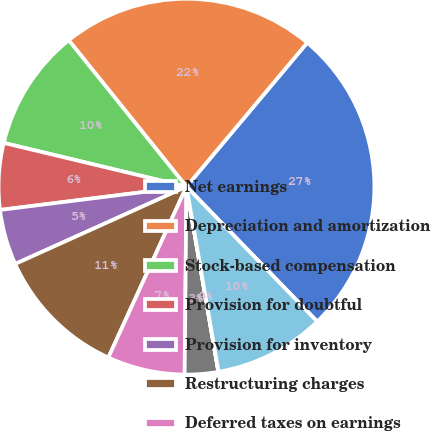Convert chart to OTSL. <chart><loc_0><loc_0><loc_500><loc_500><pie_chart><fcel>Net earnings<fcel>Depreciation and amortization<fcel>Stock-based compensation<fcel>Provision for doubtful<fcel>Provision for inventory<fcel>Restructuring charges<fcel>Deferred taxes on earnings<fcel>Excess tax benefit from<fcel>Other net<fcel>Accounts and financing<nl><fcel>26.64%<fcel>21.89%<fcel>10.48%<fcel>5.72%<fcel>4.77%<fcel>11.43%<fcel>6.67%<fcel>2.87%<fcel>0.02%<fcel>9.52%<nl></chart> 